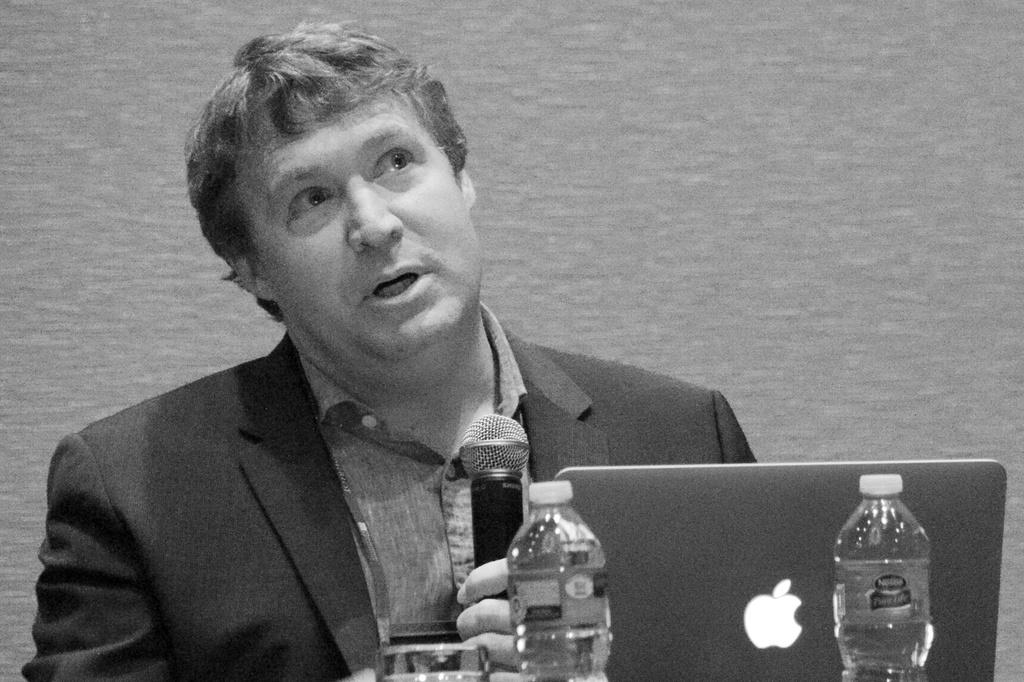What is the main subject of the image? There is a person in the image. What is the person wearing? The person is wearing a coat. What is the person doing in the image? The person is talking and holding a microphone. What objects are in front of the person? There is a laptop, bottles, and a glass in front of the person. What type of toys can be seen on the person's desk in the image? There are no toys visible in the image; the objects in front of the person include a laptop, bottles, and a glass. 